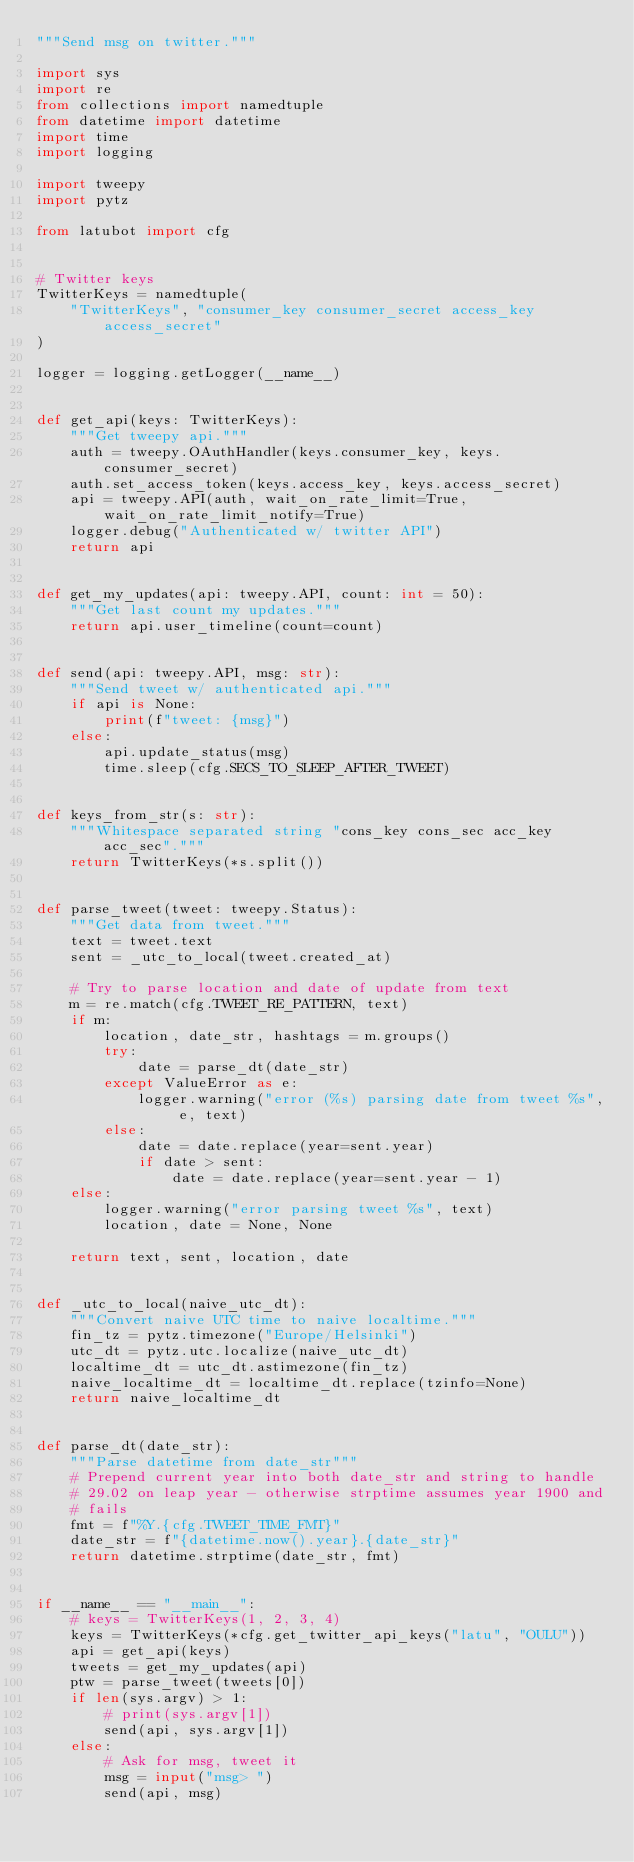Convert code to text. <code><loc_0><loc_0><loc_500><loc_500><_Python_>"""Send msg on twitter."""

import sys
import re
from collections import namedtuple
from datetime import datetime
import time
import logging

import tweepy
import pytz

from latubot import cfg


# Twitter keys
TwitterKeys = namedtuple(
    "TwitterKeys", "consumer_key consumer_secret access_key access_secret"
)

logger = logging.getLogger(__name__)


def get_api(keys: TwitterKeys):
    """Get tweepy api."""
    auth = tweepy.OAuthHandler(keys.consumer_key, keys.consumer_secret)
    auth.set_access_token(keys.access_key, keys.access_secret)
    api = tweepy.API(auth, wait_on_rate_limit=True, wait_on_rate_limit_notify=True)
    logger.debug("Authenticated w/ twitter API")
    return api


def get_my_updates(api: tweepy.API, count: int = 50):
    """Get last count my updates."""
    return api.user_timeline(count=count)


def send(api: tweepy.API, msg: str):
    """Send tweet w/ authenticated api."""
    if api is None:
        print(f"tweet: {msg}")
    else:
        api.update_status(msg)
        time.sleep(cfg.SECS_TO_SLEEP_AFTER_TWEET)


def keys_from_str(s: str):
    """Whitespace separated string "cons_key cons_sec acc_key acc_sec"."""
    return TwitterKeys(*s.split())


def parse_tweet(tweet: tweepy.Status):
    """Get data from tweet."""
    text = tweet.text
    sent = _utc_to_local(tweet.created_at)

    # Try to parse location and date of update from text
    m = re.match(cfg.TWEET_RE_PATTERN, text)
    if m:
        location, date_str, hashtags = m.groups()
        try:
            date = parse_dt(date_str)
        except ValueError as e:
            logger.warning("error (%s) parsing date from tweet %s", e, text)
        else:
            date = date.replace(year=sent.year)
            if date > sent:
                date = date.replace(year=sent.year - 1)
    else:
        logger.warning("error parsing tweet %s", text)
        location, date = None, None

    return text, sent, location, date


def _utc_to_local(naive_utc_dt):
    """Convert naive UTC time to naive localtime."""
    fin_tz = pytz.timezone("Europe/Helsinki")
    utc_dt = pytz.utc.localize(naive_utc_dt)
    localtime_dt = utc_dt.astimezone(fin_tz)
    naive_localtime_dt = localtime_dt.replace(tzinfo=None)
    return naive_localtime_dt


def parse_dt(date_str):
    """Parse datetime from date_str"""
    # Prepend current year into both date_str and string to handle
    # 29.02 on leap year - otherwise strptime assumes year 1900 and
    # fails
    fmt = f"%Y.{cfg.TWEET_TIME_FMT}"
    date_str = f"{datetime.now().year}.{date_str}"
    return datetime.strptime(date_str, fmt)


if __name__ == "__main__":
    # keys = TwitterKeys(1, 2, 3, 4)
    keys = TwitterKeys(*cfg.get_twitter_api_keys("latu", "OULU"))
    api = get_api(keys)
    tweets = get_my_updates(api)
    ptw = parse_tweet(tweets[0])
    if len(sys.argv) > 1:
        # print(sys.argv[1])
        send(api, sys.argv[1])
    else:
        # Ask for msg, tweet it
        msg = input("msg> ")
        send(api, msg)
</code> 